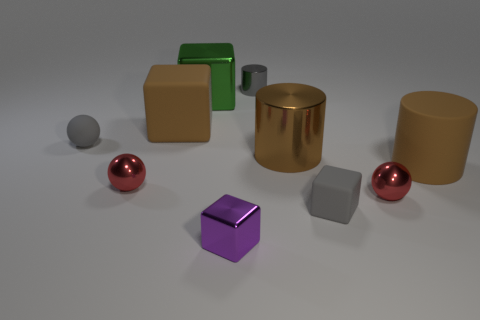Subtract all large brown cylinders. How many cylinders are left? 1 Subtract all gray cylinders. How many cylinders are left? 2 Subtract 3 cylinders. How many cylinders are left? 0 Subtract all cylinders. How many objects are left? 7 Subtract all cyan blocks. How many brown cylinders are left? 2 Subtract 0 green spheres. How many objects are left? 10 Subtract all brown cylinders. Subtract all blue spheres. How many cylinders are left? 1 Subtract all tiny gray matte balls. Subtract all gray metallic cylinders. How many objects are left? 8 Add 3 large metal objects. How many large metal objects are left? 5 Add 1 purple blocks. How many purple blocks exist? 2 